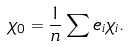<formula> <loc_0><loc_0><loc_500><loc_500>\chi _ { 0 } = \frac { 1 } { n } \sum e _ { i } \chi _ { i } .</formula> 